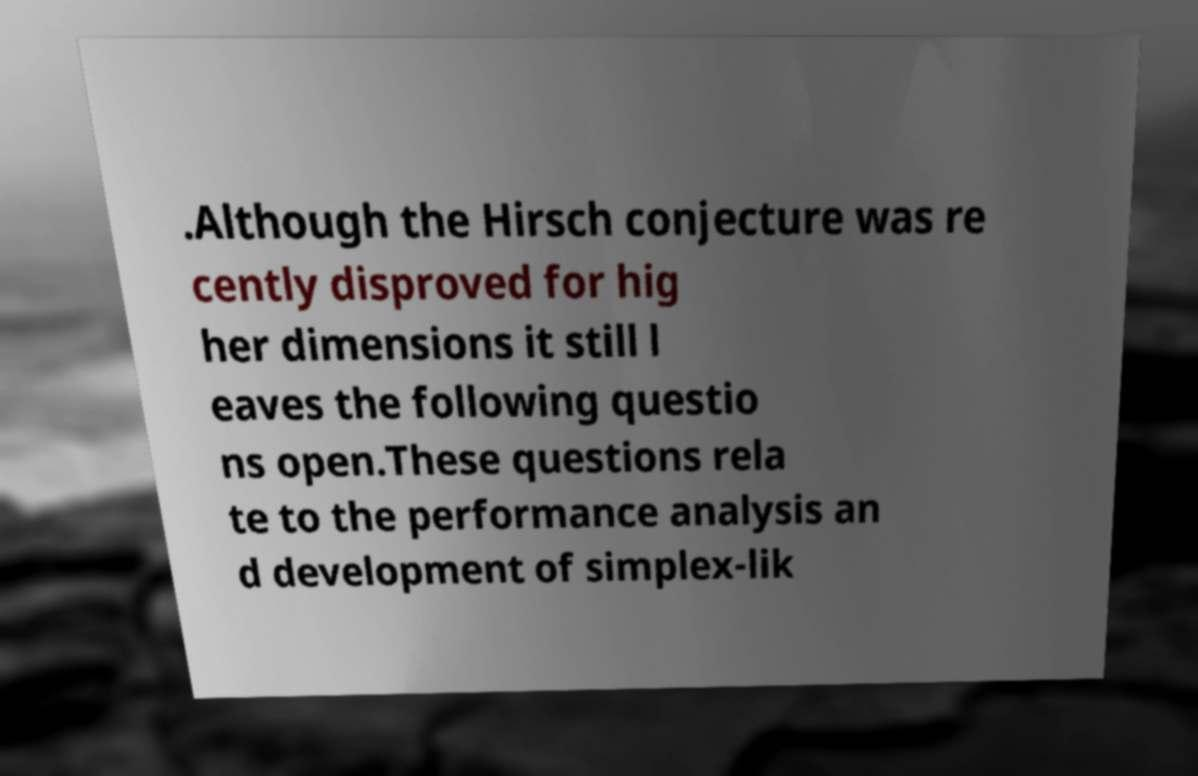There's text embedded in this image that I need extracted. Can you transcribe it verbatim? .Although the Hirsch conjecture was re cently disproved for hig her dimensions it still l eaves the following questio ns open.These questions rela te to the performance analysis an d development of simplex-lik 